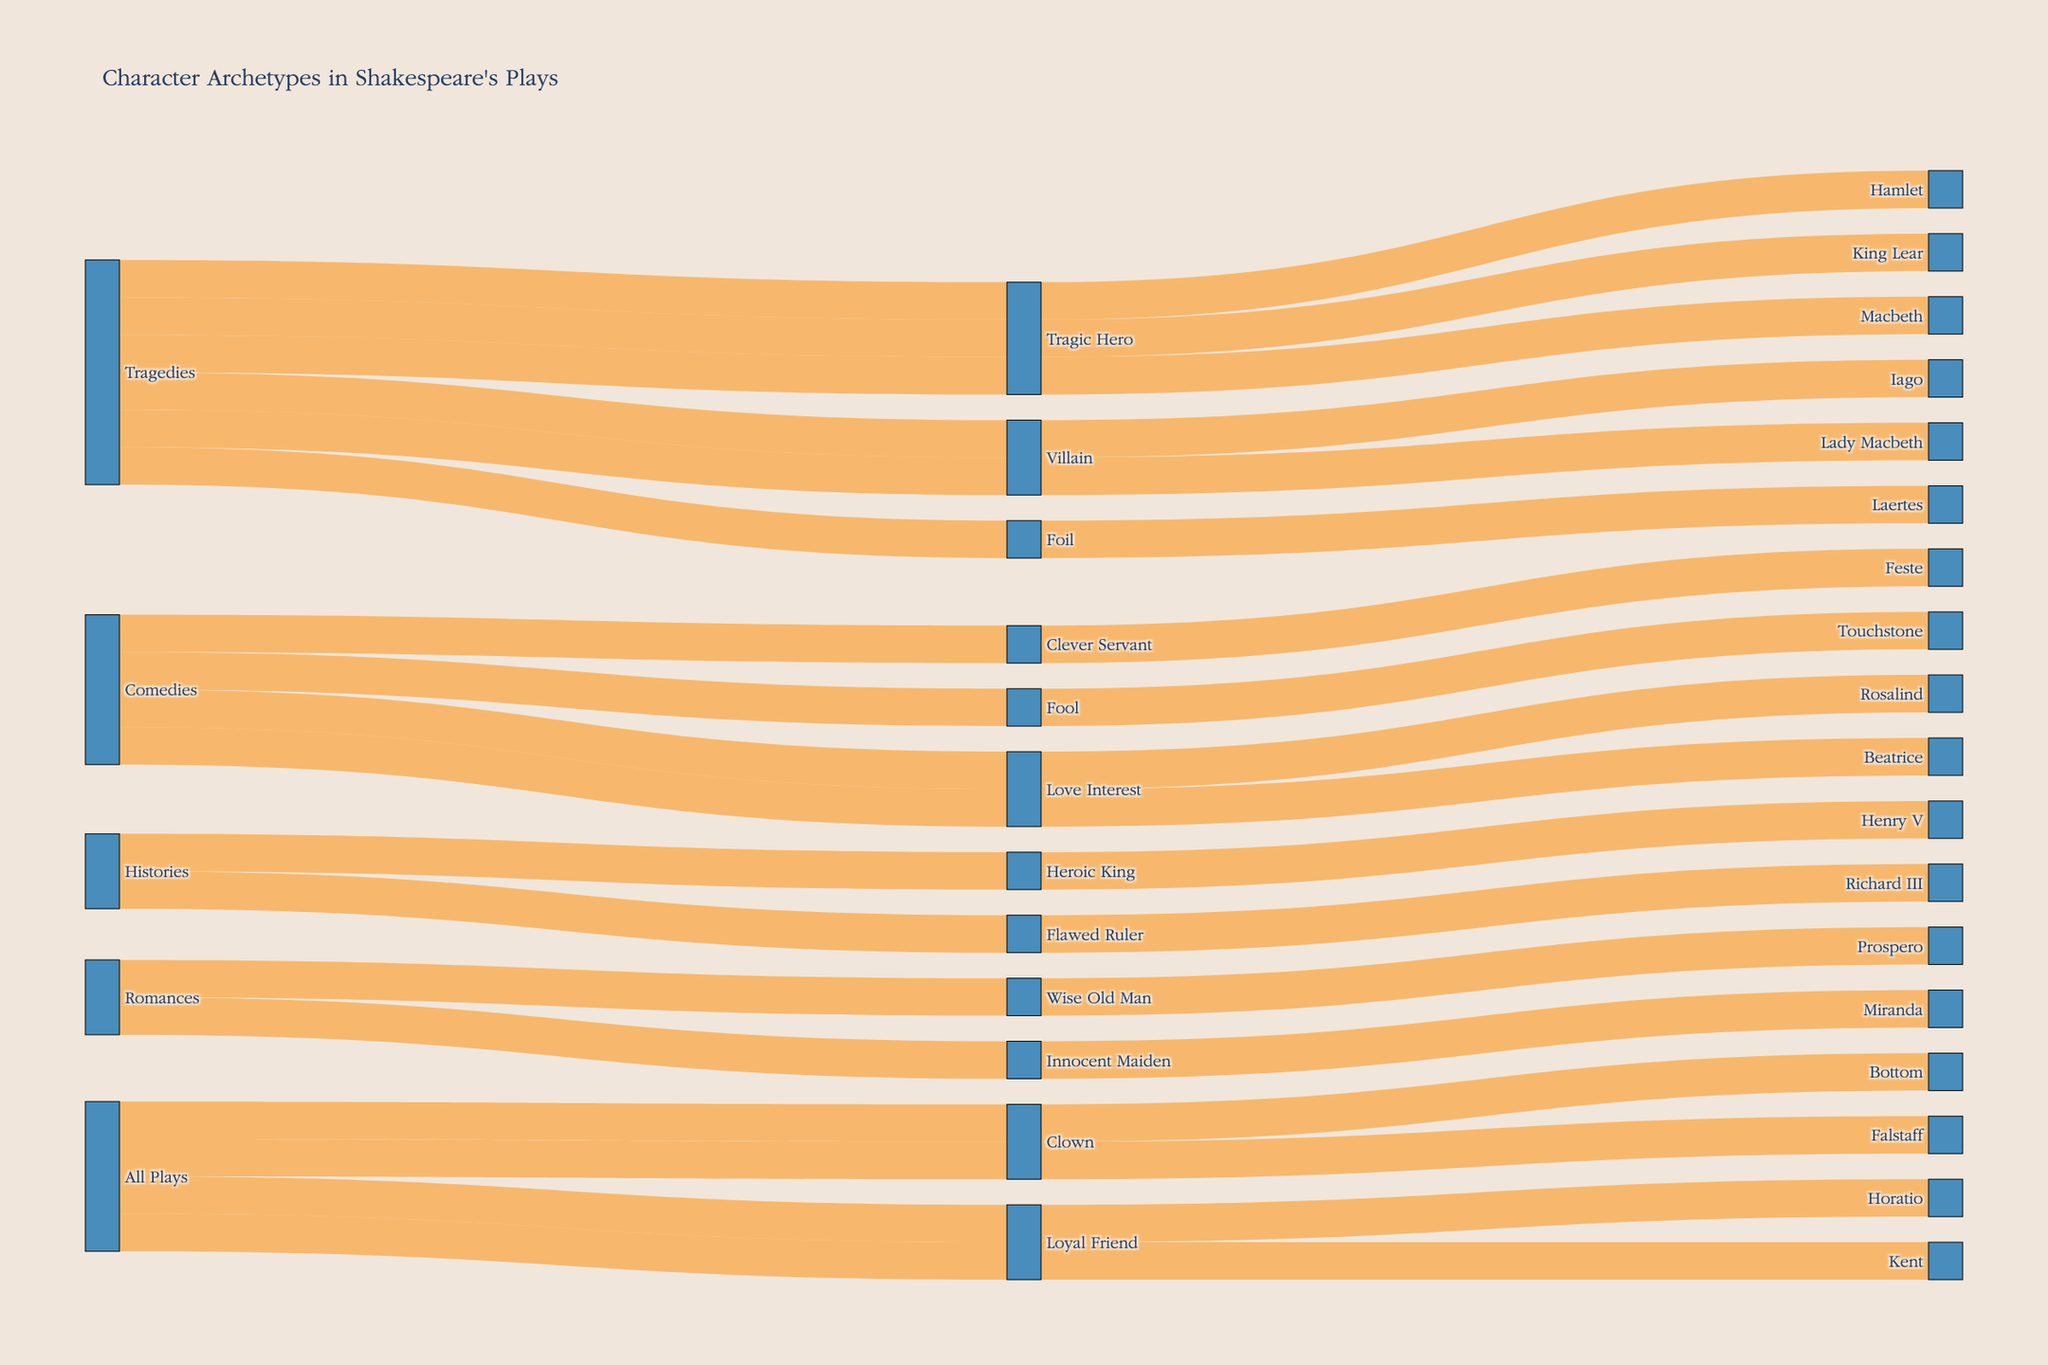What's the title of the Sankey diagram? The title of the diagram is typically placed at the top and is a textual element displaying the main subject of the visualization. The title should be clear and self-explanatory.
Answer: Character Archetypes in Shakespeare's Plays How many plays are represented in the 'Tragedies' category? To find this, look at the links between the 'Tragedies' source and the 'Character Archetype' nodes, then further look at the links from 'Character Archetype' nodes to the 'Play' nodes.
Answer: 6 Which 'Character Archetype' has connections to both 'Tragedies' and 'Comedies'? Observe the links originating from both the 'Tragedies' and 'Comedies' sources to see which 'Character Archetype' nodes receive connections from both.
Answer: Villain How many character archetypes are directly linked to the 'All Plays' category? Count the number of direct links originating from the 'All Plays' source node to different 'Character Archetype' nodes.
Answer: 2 Which play in the 'Romances' category features a character labeled as 'Wise Old Man'? Track the link from the 'Romances' source to the 'Wise Old Man' archetype, and then see which play is linked to 'Wise Old Man'.
Answer: The Tempest Compare the number of 'Loyal Friend' characters in the 'All Plays' category with 'Tragic Hero' characters in the 'Tragedies' category. Which one is greater? Count the links from 'All Plays' to 'Loyal Friend' and compare with the number of links from 'Tragedies' to 'Tragic Hero'.
Answer: Tragic Hero Which character archetype appears in the 'Comedies' category but not in any other category? Identify character archetypes linked only from 'Comedies' and not from 'Tragedies', 'Histories', 'Romances', or 'All Plays'.
Answer: Fool How many character archetypes are there in total across all plays? Sum up the unique 'Character Archetype' nodes linked from various source categories in the Sankey diagram.
Answer: 11 